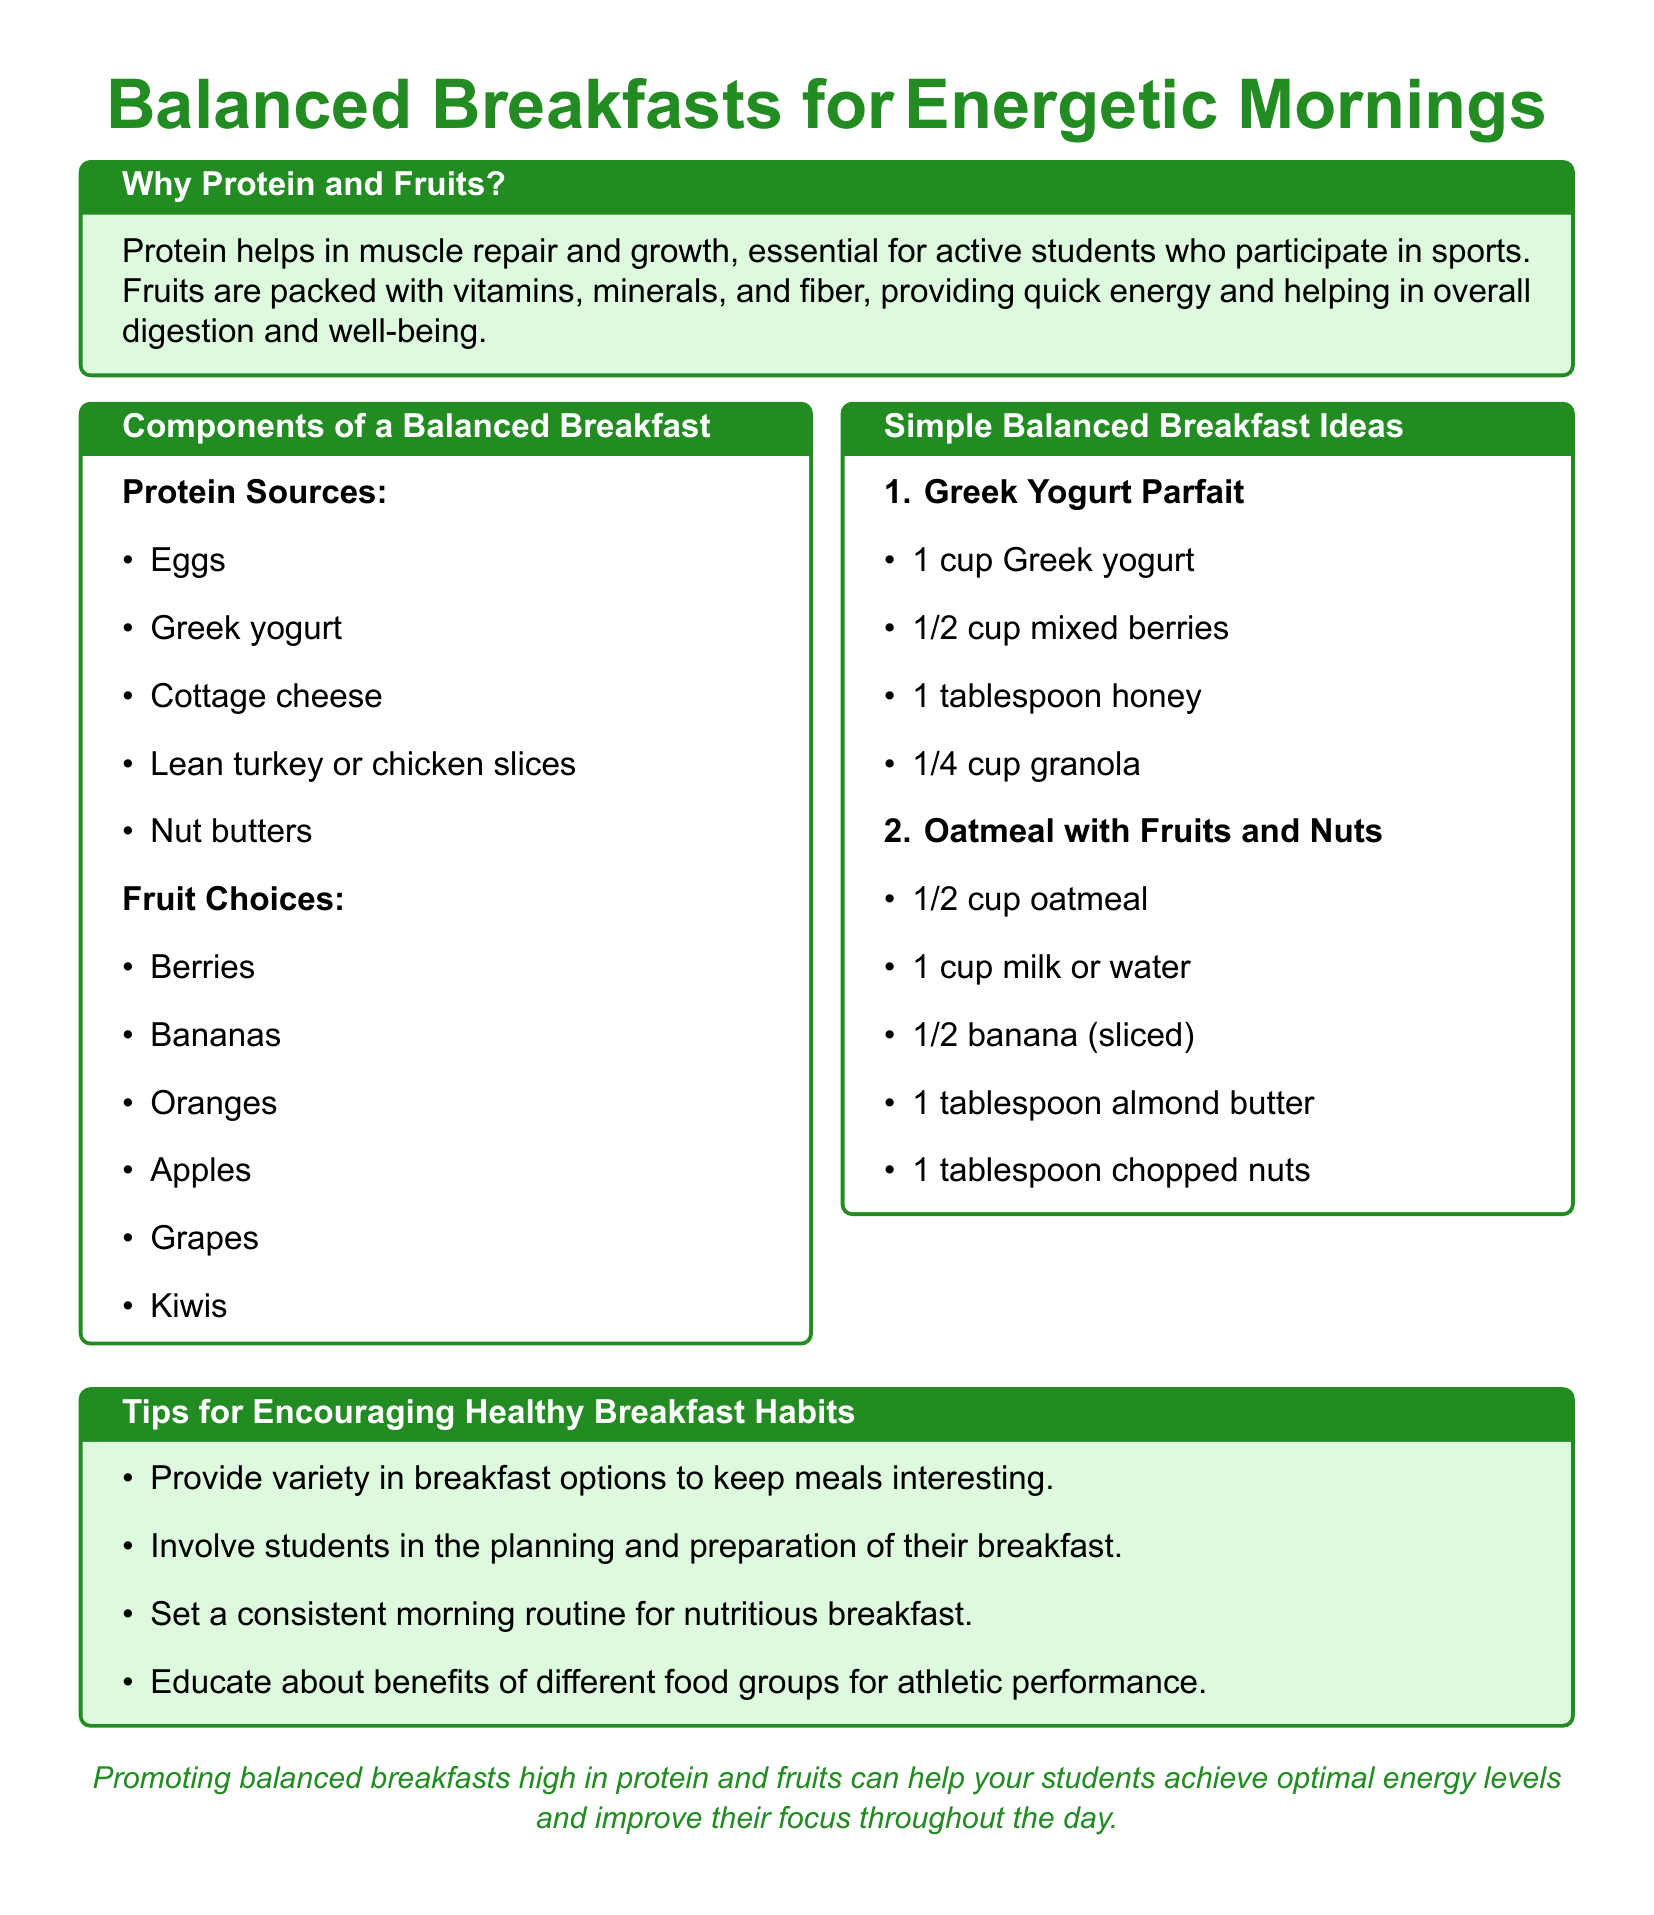What are two protein sources listed? The document lists various protein sources, including eggs and Greek yogurt.
Answer: Eggs, Greek yogurt What is one fruit choice mentioned? The document includes several fruit options such as bananas and apples.
Answer: Bananas How many breakfast ideas are provided? The document outlines a total of two simple balanced breakfast ideas.
Answer: 2 What is the main reason for including protein in breakfast? The document states that protein helps in muscle repair and growth, essential for active students.
Answer: Muscle repair and growth What is an example of a breakfast component that includes oats? The oatmeal with fruits and nuts is the breakfast idea that includes oats.
Answer: Oatmeal with fruits and nuts What color is used for the title of the document? The document uses sport green for the title text.
Answer: Sport green What food group is emphasized for athletic performance? The document educates about the benefits of different food groups, emphasizing fruits and protein sources.
Answer: Fruits, protein What type of breakfast is a Greek yogurt parfait classified as? The Greek yogurt parfait is mentioned as a simple balanced breakfast idea.
Answer: Simple balanced breakfast 